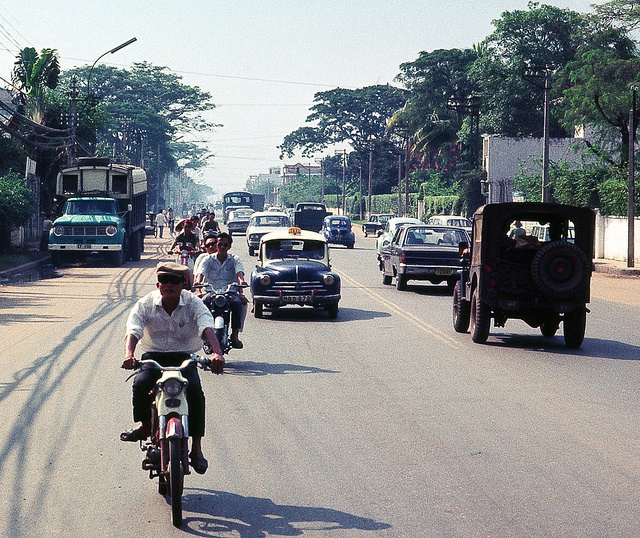Describe the objects in this image and their specific colors. I can see truck in white, black, gray, darkgray, and lightgray tones, people in white, black, gray, lightgray, and darkgray tones, truck in white, black, navy, gray, and blue tones, car in white, black, navy, ivory, and gray tones, and motorcycle in white, black, ivory, darkgray, and gray tones in this image. 